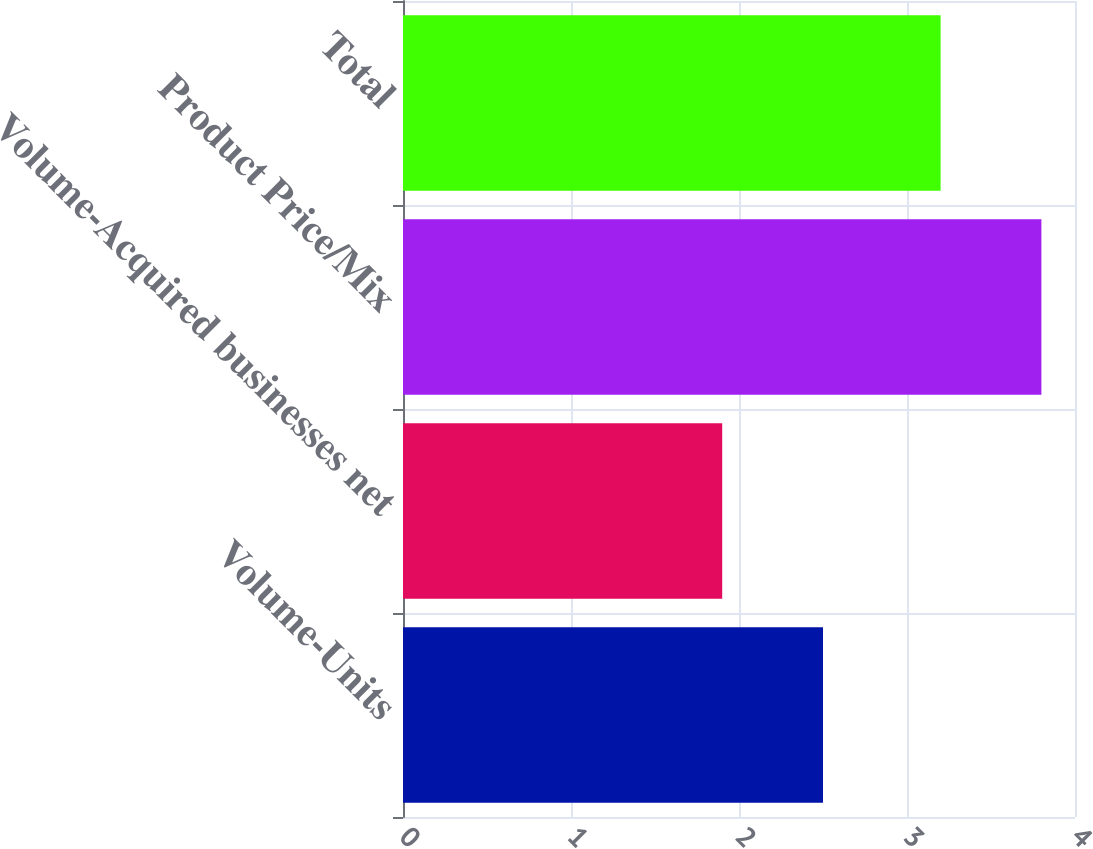<chart> <loc_0><loc_0><loc_500><loc_500><bar_chart><fcel>Volume-Units<fcel>Volume-Acquired businesses net<fcel>Product Price/Mix<fcel>Total<nl><fcel>2.5<fcel>1.9<fcel>3.8<fcel>3.2<nl></chart> 